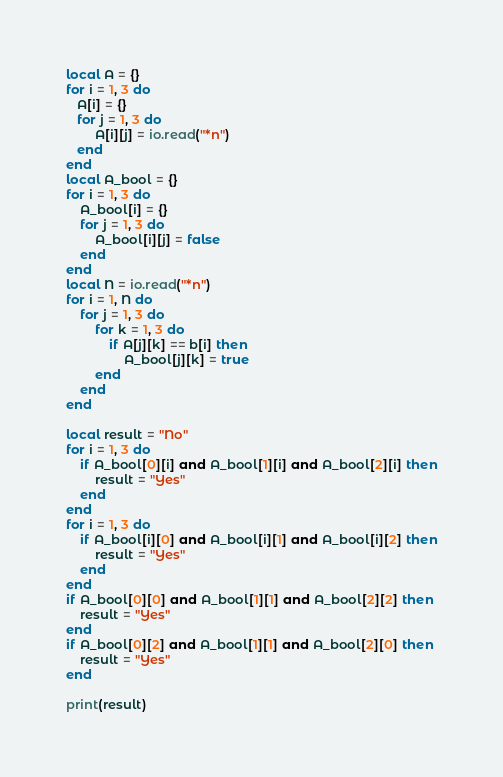Convert code to text. <code><loc_0><loc_0><loc_500><loc_500><_Lua_>local A = {}
for i = 1, 3 do
   A[i] = {}
   for j = 1, 3 do        
        A[i][j] = io.read("*n")
   end
end
local A_bool = {}
for i = 1, 3 do
    A_bool[i] = {}
    for j = 1, 3 do        
        A_bool[i][j] = false
    end
end
local N = io.read("*n")
for i = 1, N do
    for j = 1, 3 do
        for k = 1, 3 do
            if A[j][k] == b[i] then
                A_bool[j][k] = true
        end
    end
end

local result = "No"
for i = 1, 3 do
    if A_bool[0][i] and A_bool[1][i] and A_bool[2][i] then
        result = "Yes"
    end
end
for i = 1, 3 do
    if A_bool[i][0] and A_bool[i][1] and A_bool[i][2] then
        result = "Yes"
    end
end
if A_bool[0][0] and A_bool[1][1] and A_bool[2][2] then 
    result = "Yes"
end
if A_bool[0][2] and A_bool[1][1] and A_bool[2][0] then 
    result = "Yes"
end

print(result)</code> 